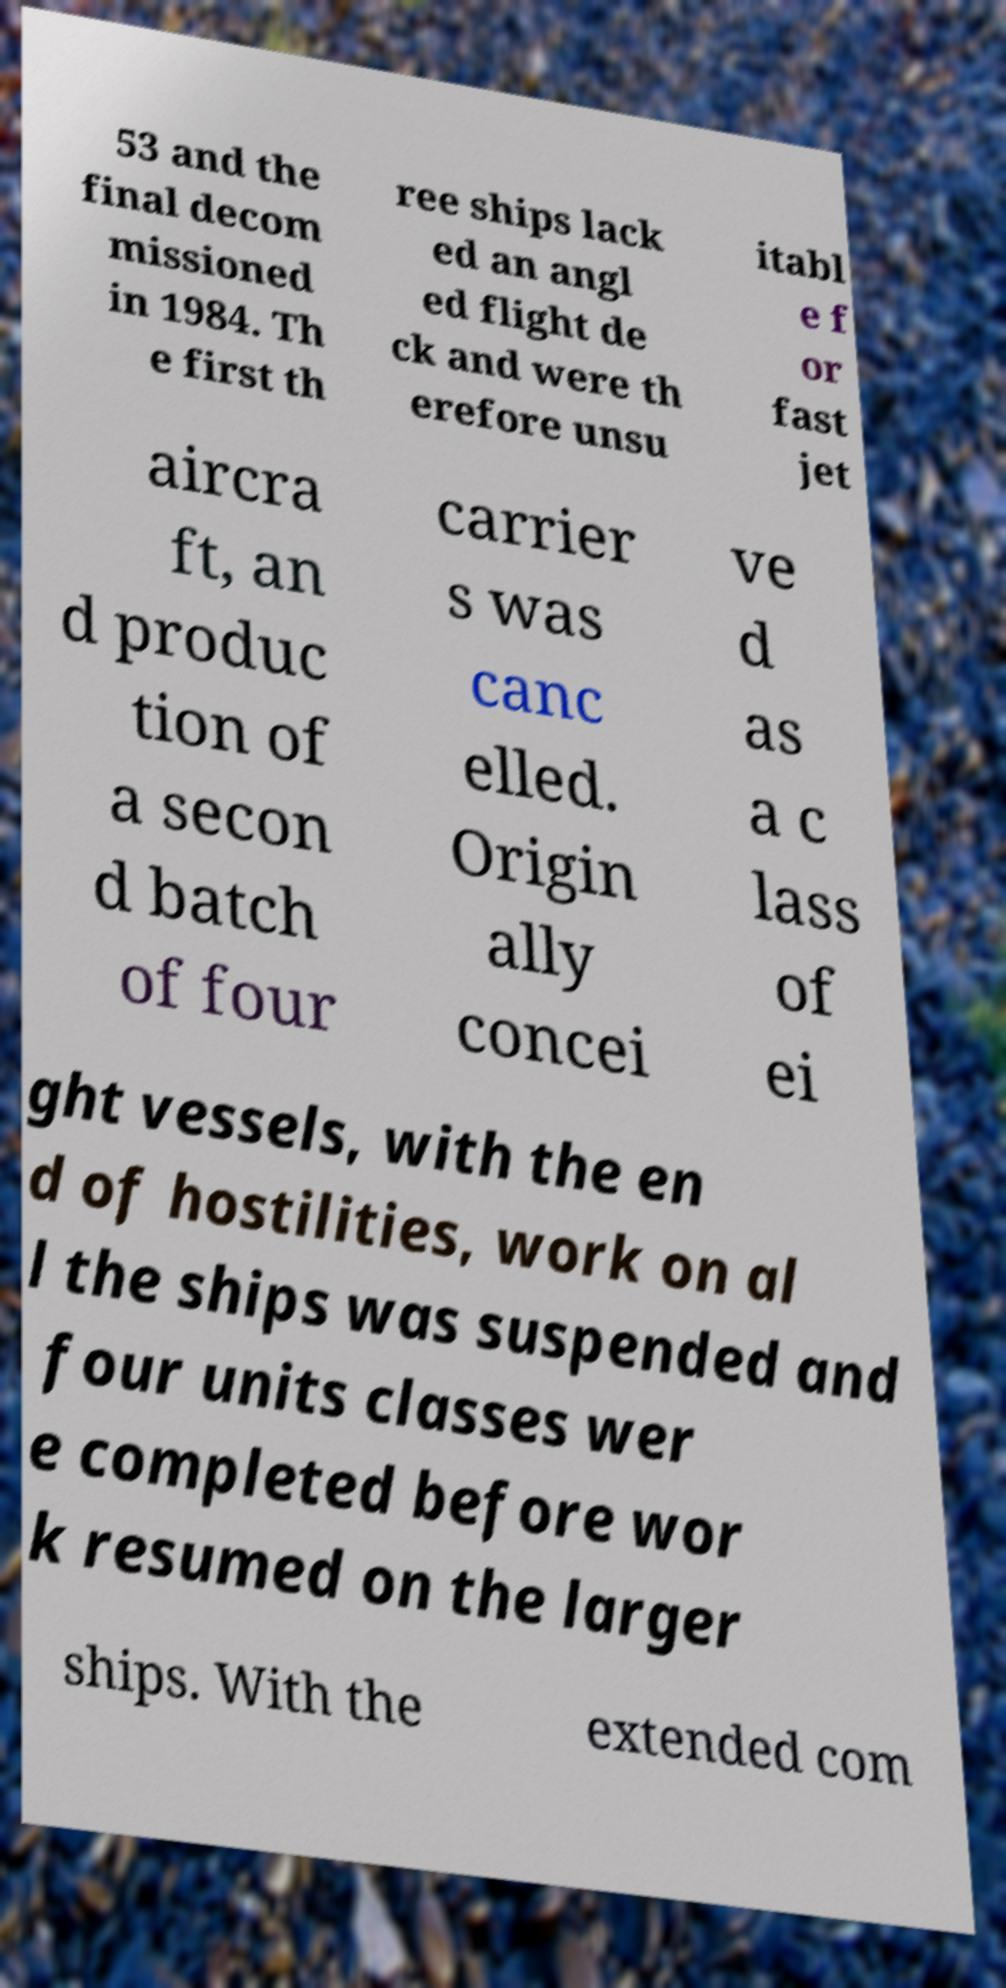Could you extract and type out the text from this image? 53 and the final decom missioned in 1984. Th e first th ree ships lack ed an angl ed flight de ck and were th erefore unsu itabl e f or fast jet aircra ft, an d produc tion of a secon d batch of four carrier s was canc elled. Origin ally concei ve d as a c lass of ei ght vessels, with the en d of hostilities, work on al l the ships was suspended and four units classes wer e completed before wor k resumed on the larger ships. With the extended com 